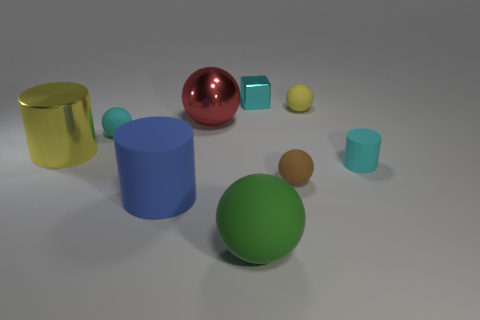There is a yellow thing that is on the right side of the red metallic thing; does it have the same size as the yellow thing on the left side of the green object?
Ensure brevity in your answer.  No. Are there any spheres behind the small cylinder?
Offer a very short reply. Yes. The large thing behind the small cyan thing left of the green object is what color?
Keep it short and to the point. Red. Are there fewer yellow metal objects than tiny green spheres?
Give a very brief answer. No. How many tiny rubber objects are the same shape as the red shiny object?
Offer a terse response. 3. What color is the shiny thing that is the same size as the yellow metal cylinder?
Your response must be concise. Red. Are there the same number of small cyan matte things on the left side of the large red sphere and small brown balls that are in front of the small rubber cylinder?
Provide a succinct answer. Yes. Is there another rubber cylinder of the same size as the blue cylinder?
Give a very brief answer. No. What is the size of the yellow matte sphere?
Provide a short and direct response. Small. Are there the same number of big red objects right of the shiny sphere and gray cylinders?
Make the answer very short. Yes. 